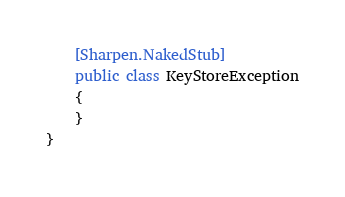Convert code to text. <code><loc_0><loc_0><loc_500><loc_500><_C#_>	[Sharpen.NakedStub]
	public class KeyStoreException
	{
	}
}
</code> 